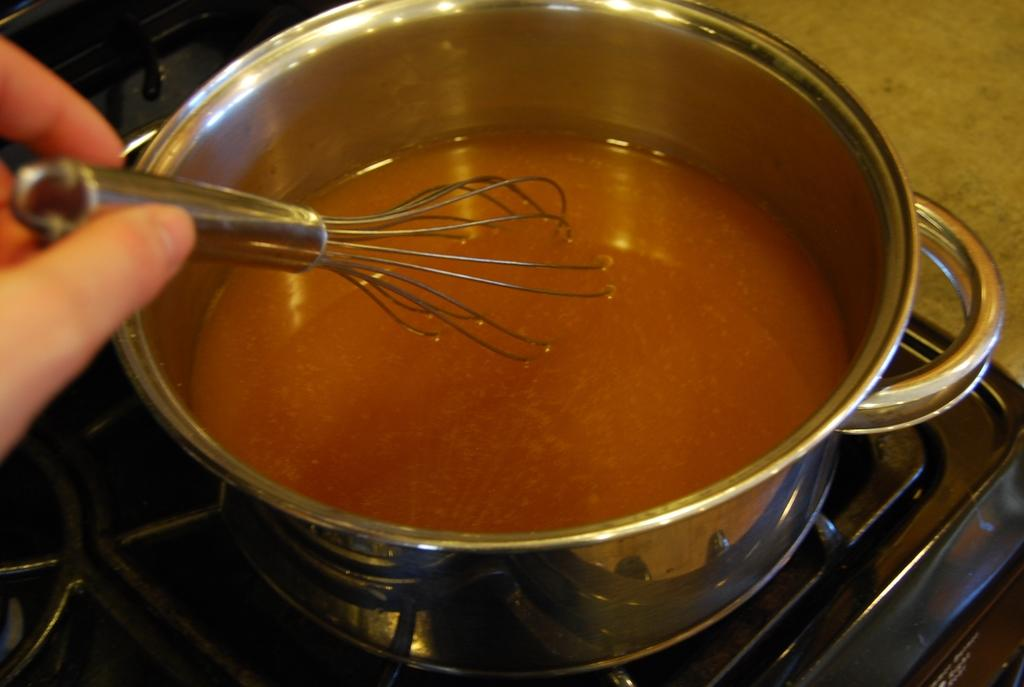What is in the cooking pot that is visible in the image? There is a cooking pot with liquid in the image. What is the cooking pot placed on? The cooking pot is placed on a black stove. What is the person in the image doing with their hands? Human fingers are visible in the image, and they are holding a steel whisker. What can be seen in the top right corner of the image? There is a surface visible in the top right corner of the image. What type of flag is being used as a lunch mat in the image? There is no flag or lunch mat present in the image. How many bags are visible in the image? There are no bags visible in the image. 